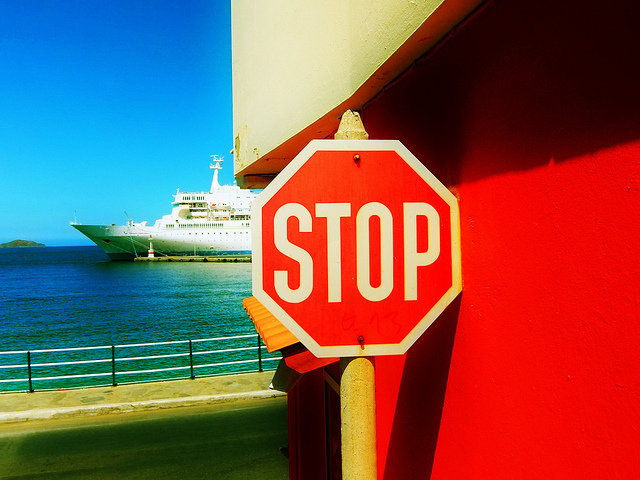How many stop signs are visible? In the image provided, there is a single stop sign that is visible. It is octagonal in shape with a bold, white border and the word 'STOP' written in prominent white letters, which is the standard design for such traffic signage in many countries, providing a universally recognized command for drivers to halt their vehicles before proceeding. 